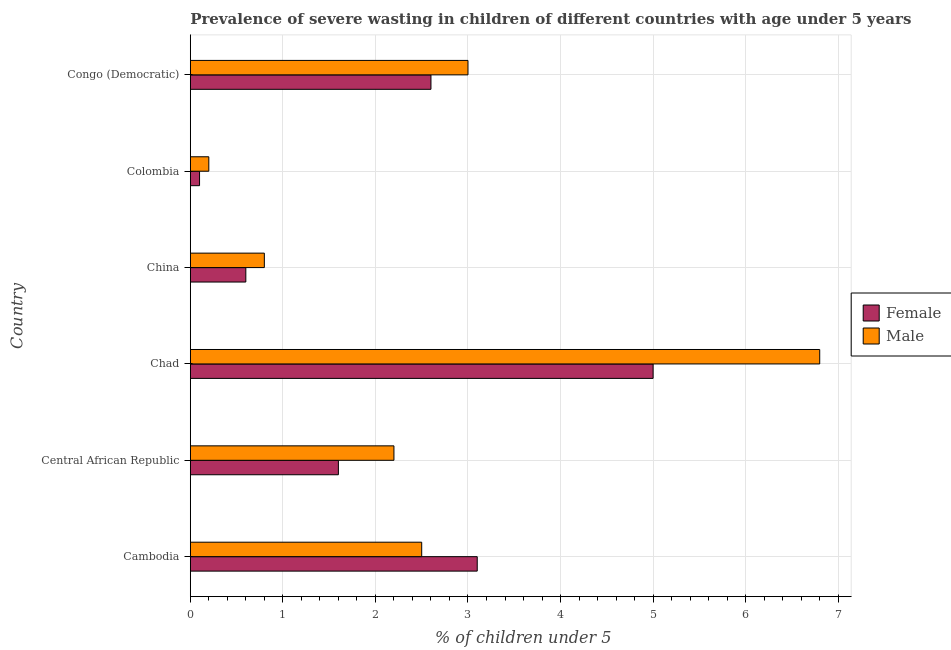How many groups of bars are there?
Give a very brief answer. 6. Are the number of bars per tick equal to the number of legend labels?
Ensure brevity in your answer.  Yes. Are the number of bars on each tick of the Y-axis equal?
Offer a very short reply. Yes. How many bars are there on the 4th tick from the top?
Your answer should be very brief. 2. How many bars are there on the 2nd tick from the bottom?
Your response must be concise. 2. What is the label of the 4th group of bars from the top?
Provide a succinct answer. Chad. In how many cases, is the number of bars for a given country not equal to the number of legend labels?
Your response must be concise. 0. What is the percentage of undernourished male children in Colombia?
Your answer should be compact. 0.2. Across all countries, what is the maximum percentage of undernourished male children?
Give a very brief answer. 6.8. Across all countries, what is the minimum percentage of undernourished female children?
Ensure brevity in your answer.  0.1. In which country was the percentage of undernourished female children maximum?
Make the answer very short. Chad. In which country was the percentage of undernourished female children minimum?
Your response must be concise. Colombia. What is the total percentage of undernourished male children in the graph?
Offer a very short reply. 15.5. What is the difference between the percentage of undernourished male children in China and the percentage of undernourished female children in Cambodia?
Your answer should be compact. -2.3. What is the average percentage of undernourished male children per country?
Your answer should be very brief. 2.58. What is the difference between the percentage of undernourished male children and percentage of undernourished female children in Congo (Democratic)?
Provide a short and direct response. 0.4. What is the ratio of the percentage of undernourished female children in Central African Republic to that in Congo (Democratic)?
Offer a very short reply. 0.61. Is the difference between the percentage of undernourished male children in Chad and Colombia greater than the difference between the percentage of undernourished female children in Chad and Colombia?
Your response must be concise. Yes. What is the difference between the highest and the second highest percentage of undernourished female children?
Your answer should be very brief. 1.9. What is the difference between the highest and the lowest percentage of undernourished female children?
Your answer should be very brief. 4.9. In how many countries, is the percentage of undernourished female children greater than the average percentage of undernourished female children taken over all countries?
Ensure brevity in your answer.  3. Is the sum of the percentage of undernourished male children in China and Colombia greater than the maximum percentage of undernourished female children across all countries?
Make the answer very short. No. What does the 1st bar from the top in Chad represents?
Your answer should be compact. Male. What does the 1st bar from the bottom in Chad represents?
Keep it short and to the point. Female. How many bars are there?
Provide a short and direct response. 12. Are all the bars in the graph horizontal?
Provide a succinct answer. Yes. Does the graph contain any zero values?
Your answer should be compact. No. How many legend labels are there?
Your answer should be compact. 2. What is the title of the graph?
Offer a terse response. Prevalence of severe wasting in children of different countries with age under 5 years. What is the label or title of the X-axis?
Your response must be concise.  % of children under 5. What is the  % of children under 5 of Female in Cambodia?
Your answer should be compact. 3.1. What is the  % of children under 5 of Female in Central African Republic?
Your response must be concise. 1.6. What is the  % of children under 5 of Male in Central African Republic?
Make the answer very short. 2.2. What is the  % of children under 5 in Female in Chad?
Your answer should be compact. 5. What is the  % of children under 5 in Male in Chad?
Your response must be concise. 6.8. What is the  % of children under 5 in Female in China?
Your answer should be very brief. 0.6. What is the  % of children under 5 in Male in China?
Offer a terse response. 0.8. What is the  % of children under 5 of Female in Colombia?
Your answer should be compact. 0.1. What is the  % of children under 5 in Male in Colombia?
Your response must be concise. 0.2. What is the  % of children under 5 in Female in Congo (Democratic)?
Ensure brevity in your answer.  2.6. What is the  % of children under 5 of Male in Congo (Democratic)?
Your response must be concise. 3. Across all countries, what is the maximum  % of children under 5 in Male?
Offer a very short reply. 6.8. Across all countries, what is the minimum  % of children under 5 of Female?
Provide a short and direct response. 0.1. Across all countries, what is the minimum  % of children under 5 in Male?
Your answer should be compact. 0.2. What is the difference between the  % of children under 5 in Female in Cambodia and that in Central African Republic?
Provide a succinct answer. 1.5. What is the difference between the  % of children under 5 in Male in Cambodia and that in Central African Republic?
Your response must be concise. 0.3. What is the difference between the  % of children under 5 of Male in Cambodia and that in Chad?
Provide a succinct answer. -4.3. What is the difference between the  % of children under 5 of Female in Cambodia and that in China?
Your response must be concise. 2.5. What is the difference between the  % of children under 5 of Male in Cambodia and that in China?
Your answer should be compact. 1.7. What is the difference between the  % of children under 5 of Male in Cambodia and that in Colombia?
Give a very brief answer. 2.3. What is the difference between the  % of children under 5 of Female in Cambodia and that in Congo (Democratic)?
Keep it short and to the point. 0.5. What is the difference between the  % of children under 5 in Male in Cambodia and that in Congo (Democratic)?
Ensure brevity in your answer.  -0.5. What is the difference between the  % of children under 5 in Female in Central African Republic and that in Chad?
Your response must be concise. -3.4. What is the difference between the  % of children under 5 in Female in Central African Republic and that in China?
Provide a succinct answer. 1. What is the difference between the  % of children under 5 of Female in Central African Republic and that in Colombia?
Provide a short and direct response. 1.5. What is the difference between the  % of children under 5 in Male in Central African Republic and that in Colombia?
Ensure brevity in your answer.  2. What is the difference between the  % of children under 5 in Female in Central African Republic and that in Congo (Democratic)?
Your answer should be very brief. -1. What is the difference between the  % of children under 5 of Female in Chad and that in Congo (Democratic)?
Provide a short and direct response. 2.4. What is the difference between the  % of children under 5 of Female in China and that in Colombia?
Offer a very short reply. 0.5. What is the difference between the  % of children under 5 in Female in Colombia and that in Congo (Democratic)?
Keep it short and to the point. -2.5. What is the difference between the  % of children under 5 of Male in Colombia and that in Congo (Democratic)?
Provide a short and direct response. -2.8. What is the difference between the  % of children under 5 of Female in Cambodia and the  % of children under 5 of Male in Central African Republic?
Keep it short and to the point. 0.9. What is the difference between the  % of children under 5 in Female in Cambodia and the  % of children under 5 in Male in China?
Ensure brevity in your answer.  2.3. What is the difference between the  % of children under 5 in Female in Cambodia and the  % of children under 5 in Male in Congo (Democratic)?
Your answer should be compact. 0.1. What is the difference between the  % of children under 5 in Female in Central African Republic and the  % of children under 5 in Male in China?
Make the answer very short. 0.8. What is the difference between the  % of children under 5 of Female in Central African Republic and the  % of children under 5 of Male in Congo (Democratic)?
Your answer should be very brief. -1.4. What is the difference between the  % of children under 5 of Female in Colombia and the  % of children under 5 of Male in Congo (Democratic)?
Your answer should be very brief. -2.9. What is the average  % of children under 5 of Female per country?
Provide a succinct answer. 2.17. What is the average  % of children under 5 of Male per country?
Your answer should be very brief. 2.58. What is the difference between the  % of children under 5 of Female and  % of children under 5 of Male in Central African Republic?
Ensure brevity in your answer.  -0.6. What is the difference between the  % of children under 5 in Female and  % of children under 5 in Male in Chad?
Offer a very short reply. -1.8. What is the difference between the  % of children under 5 in Female and  % of children under 5 in Male in China?
Your answer should be very brief. -0.2. What is the ratio of the  % of children under 5 in Female in Cambodia to that in Central African Republic?
Give a very brief answer. 1.94. What is the ratio of the  % of children under 5 of Male in Cambodia to that in Central African Republic?
Give a very brief answer. 1.14. What is the ratio of the  % of children under 5 of Female in Cambodia to that in Chad?
Ensure brevity in your answer.  0.62. What is the ratio of the  % of children under 5 of Male in Cambodia to that in Chad?
Make the answer very short. 0.37. What is the ratio of the  % of children under 5 of Female in Cambodia to that in China?
Your answer should be very brief. 5.17. What is the ratio of the  % of children under 5 in Male in Cambodia to that in China?
Your response must be concise. 3.12. What is the ratio of the  % of children under 5 in Female in Cambodia to that in Colombia?
Offer a terse response. 31. What is the ratio of the  % of children under 5 of Female in Cambodia to that in Congo (Democratic)?
Your response must be concise. 1.19. What is the ratio of the  % of children under 5 in Male in Cambodia to that in Congo (Democratic)?
Provide a succinct answer. 0.83. What is the ratio of the  % of children under 5 of Female in Central African Republic to that in Chad?
Offer a terse response. 0.32. What is the ratio of the  % of children under 5 in Male in Central African Republic to that in Chad?
Make the answer very short. 0.32. What is the ratio of the  % of children under 5 in Female in Central African Republic to that in China?
Provide a short and direct response. 2.67. What is the ratio of the  % of children under 5 in Male in Central African Republic to that in China?
Your response must be concise. 2.75. What is the ratio of the  % of children under 5 in Female in Central African Republic to that in Congo (Democratic)?
Your answer should be compact. 0.62. What is the ratio of the  % of children under 5 of Male in Central African Republic to that in Congo (Democratic)?
Ensure brevity in your answer.  0.73. What is the ratio of the  % of children under 5 in Female in Chad to that in China?
Your answer should be very brief. 8.33. What is the ratio of the  % of children under 5 of Female in Chad to that in Colombia?
Give a very brief answer. 50. What is the ratio of the  % of children under 5 of Male in Chad to that in Colombia?
Your answer should be very brief. 34. What is the ratio of the  % of children under 5 in Female in Chad to that in Congo (Democratic)?
Ensure brevity in your answer.  1.92. What is the ratio of the  % of children under 5 of Male in Chad to that in Congo (Democratic)?
Your answer should be compact. 2.27. What is the ratio of the  % of children under 5 in Female in China to that in Colombia?
Make the answer very short. 6. What is the ratio of the  % of children under 5 in Female in China to that in Congo (Democratic)?
Provide a succinct answer. 0.23. What is the ratio of the  % of children under 5 of Male in China to that in Congo (Democratic)?
Make the answer very short. 0.27. What is the ratio of the  % of children under 5 in Female in Colombia to that in Congo (Democratic)?
Keep it short and to the point. 0.04. What is the ratio of the  % of children under 5 in Male in Colombia to that in Congo (Democratic)?
Ensure brevity in your answer.  0.07. What is the difference between the highest and the second highest  % of children under 5 of Female?
Your answer should be very brief. 1.9. What is the difference between the highest and the second highest  % of children under 5 in Male?
Your response must be concise. 3.8. What is the difference between the highest and the lowest  % of children under 5 in Female?
Your response must be concise. 4.9. 